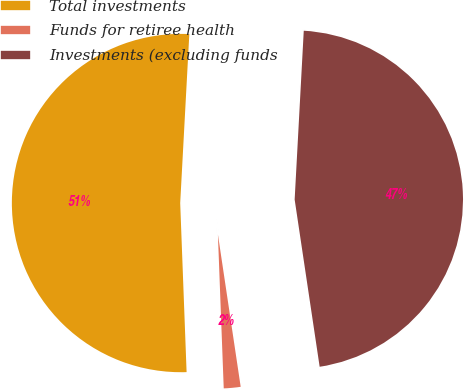<chart> <loc_0><loc_0><loc_500><loc_500><pie_chart><fcel>Total investments<fcel>Funds for retiree health<fcel>Investments (excluding funds<nl><fcel>51.46%<fcel>1.76%<fcel>46.78%<nl></chart> 